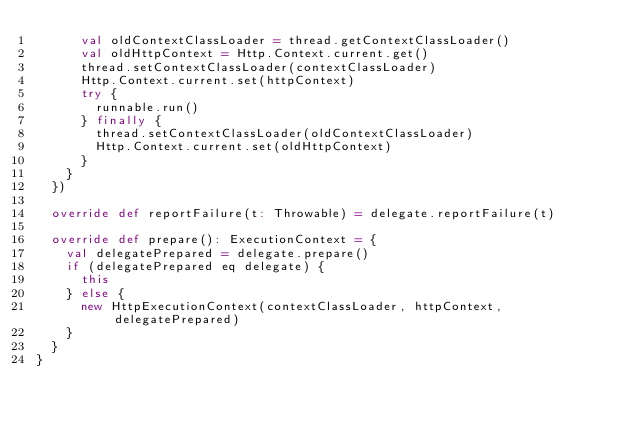<code> <loc_0><loc_0><loc_500><loc_500><_Scala_>      val oldContextClassLoader = thread.getContextClassLoader()
      val oldHttpContext = Http.Context.current.get()
      thread.setContextClassLoader(contextClassLoader)
      Http.Context.current.set(httpContext)
      try {
        runnable.run()
      } finally {
        thread.setContextClassLoader(oldContextClassLoader)
        Http.Context.current.set(oldHttpContext)
      }
    }
  })

  override def reportFailure(t: Throwable) = delegate.reportFailure(t)

  override def prepare(): ExecutionContext = {
    val delegatePrepared = delegate.prepare()
    if (delegatePrepared eq delegate) {
      this
    } else {
      new HttpExecutionContext(contextClassLoader, httpContext, delegatePrepared)
    }
  }
}</code> 